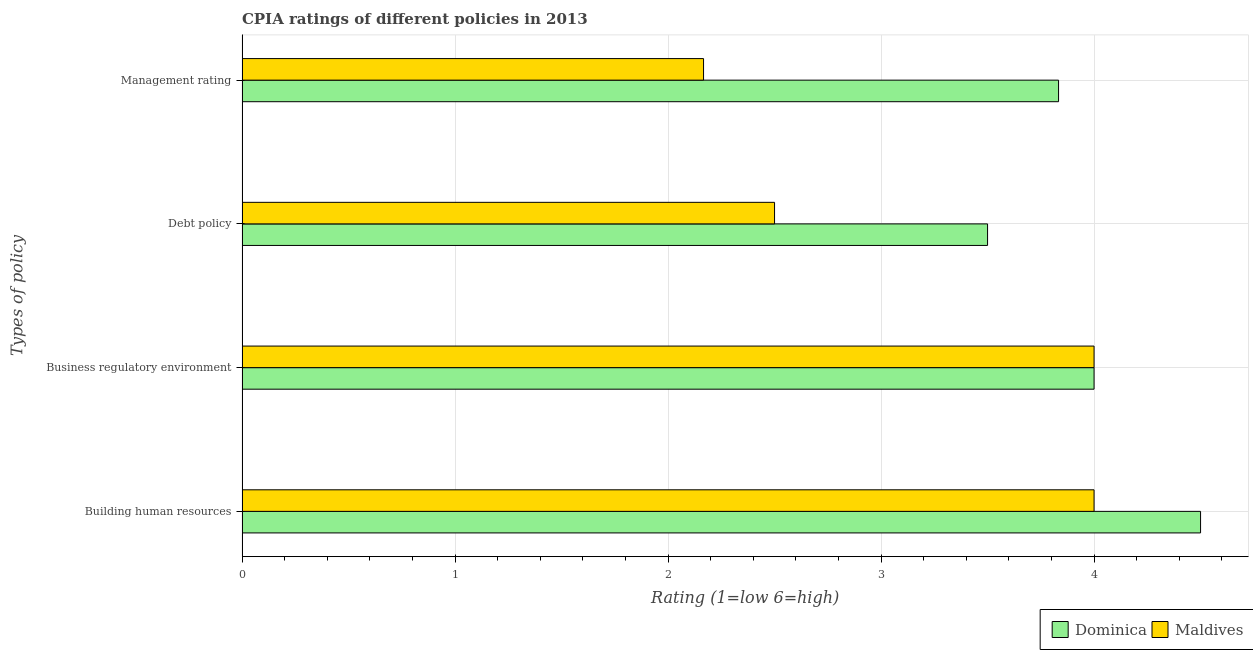Are the number of bars on each tick of the Y-axis equal?
Provide a short and direct response. Yes. How many bars are there on the 2nd tick from the top?
Offer a terse response. 2. What is the label of the 2nd group of bars from the top?
Your response must be concise. Debt policy. What is the cpia rating of debt policy in Dominica?
Provide a short and direct response. 3.5. Across all countries, what is the maximum cpia rating of management?
Make the answer very short. 3.83. In which country was the cpia rating of management maximum?
Your answer should be very brief. Dominica. In which country was the cpia rating of debt policy minimum?
Offer a very short reply. Maldives. What is the total cpia rating of building human resources in the graph?
Make the answer very short. 8.5. What is the difference between the cpia rating of debt policy in Maldives and that in Dominica?
Offer a terse response. -1. What is the difference between the cpia rating of management and cpia rating of debt policy in Maldives?
Your answer should be compact. -0.33. Is the cpia rating of management in Maldives less than that in Dominica?
Your answer should be compact. Yes. Is the difference between the cpia rating of building human resources in Dominica and Maldives greater than the difference between the cpia rating of management in Dominica and Maldives?
Give a very brief answer. No. What is the difference between the highest and the lowest cpia rating of building human resources?
Offer a very short reply. 0.5. In how many countries, is the cpia rating of building human resources greater than the average cpia rating of building human resources taken over all countries?
Your response must be concise. 1. Is the sum of the cpia rating of management in Dominica and Maldives greater than the maximum cpia rating of building human resources across all countries?
Your answer should be compact. Yes. What does the 2nd bar from the top in Management rating represents?
Your answer should be very brief. Dominica. What does the 2nd bar from the bottom in Debt policy represents?
Your answer should be compact. Maldives. How many bars are there?
Ensure brevity in your answer.  8. What is the difference between two consecutive major ticks on the X-axis?
Provide a short and direct response. 1. Are the values on the major ticks of X-axis written in scientific E-notation?
Keep it short and to the point. No. Does the graph contain grids?
Make the answer very short. Yes. Where does the legend appear in the graph?
Your response must be concise. Bottom right. How are the legend labels stacked?
Keep it short and to the point. Horizontal. What is the title of the graph?
Your answer should be very brief. CPIA ratings of different policies in 2013. What is the label or title of the Y-axis?
Provide a short and direct response. Types of policy. What is the Rating (1=low 6=high) of Dominica in Building human resources?
Provide a succinct answer. 4.5. What is the Rating (1=low 6=high) in Maldives in Building human resources?
Provide a short and direct response. 4. What is the Rating (1=low 6=high) in Dominica in Debt policy?
Provide a succinct answer. 3.5. What is the Rating (1=low 6=high) of Dominica in Management rating?
Provide a succinct answer. 3.83. What is the Rating (1=low 6=high) of Maldives in Management rating?
Give a very brief answer. 2.17. Across all Types of policy, what is the maximum Rating (1=low 6=high) of Dominica?
Give a very brief answer. 4.5. Across all Types of policy, what is the minimum Rating (1=low 6=high) of Dominica?
Provide a short and direct response. 3.5. Across all Types of policy, what is the minimum Rating (1=low 6=high) in Maldives?
Make the answer very short. 2.17. What is the total Rating (1=low 6=high) in Dominica in the graph?
Offer a terse response. 15.83. What is the total Rating (1=low 6=high) in Maldives in the graph?
Your answer should be very brief. 12.67. What is the difference between the Rating (1=low 6=high) in Dominica in Building human resources and that in Debt policy?
Provide a succinct answer. 1. What is the difference between the Rating (1=low 6=high) in Dominica in Building human resources and that in Management rating?
Make the answer very short. 0.67. What is the difference between the Rating (1=low 6=high) in Maldives in Building human resources and that in Management rating?
Your response must be concise. 1.83. What is the difference between the Rating (1=low 6=high) of Maldives in Business regulatory environment and that in Debt policy?
Your response must be concise. 1.5. What is the difference between the Rating (1=low 6=high) of Maldives in Business regulatory environment and that in Management rating?
Your answer should be compact. 1.83. What is the difference between the Rating (1=low 6=high) in Maldives in Debt policy and that in Management rating?
Provide a short and direct response. 0.33. What is the difference between the Rating (1=low 6=high) of Dominica in Building human resources and the Rating (1=low 6=high) of Maldives in Management rating?
Keep it short and to the point. 2.33. What is the difference between the Rating (1=low 6=high) of Dominica in Business regulatory environment and the Rating (1=low 6=high) of Maldives in Debt policy?
Your answer should be very brief. 1.5. What is the difference between the Rating (1=low 6=high) of Dominica in Business regulatory environment and the Rating (1=low 6=high) of Maldives in Management rating?
Your answer should be very brief. 1.83. What is the difference between the Rating (1=low 6=high) in Dominica in Debt policy and the Rating (1=low 6=high) in Maldives in Management rating?
Provide a short and direct response. 1.33. What is the average Rating (1=low 6=high) in Dominica per Types of policy?
Your answer should be compact. 3.96. What is the average Rating (1=low 6=high) in Maldives per Types of policy?
Provide a short and direct response. 3.17. What is the ratio of the Rating (1=low 6=high) in Dominica in Building human resources to that in Debt policy?
Offer a very short reply. 1.29. What is the ratio of the Rating (1=low 6=high) of Dominica in Building human resources to that in Management rating?
Keep it short and to the point. 1.17. What is the ratio of the Rating (1=low 6=high) of Maldives in Building human resources to that in Management rating?
Offer a very short reply. 1.85. What is the ratio of the Rating (1=low 6=high) in Dominica in Business regulatory environment to that in Debt policy?
Keep it short and to the point. 1.14. What is the ratio of the Rating (1=low 6=high) of Dominica in Business regulatory environment to that in Management rating?
Ensure brevity in your answer.  1.04. What is the ratio of the Rating (1=low 6=high) of Maldives in Business regulatory environment to that in Management rating?
Your answer should be very brief. 1.85. What is the ratio of the Rating (1=low 6=high) in Dominica in Debt policy to that in Management rating?
Ensure brevity in your answer.  0.91. What is the ratio of the Rating (1=low 6=high) of Maldives in Debt policy to that in Management rating?
Provide a succinct answer. 1.15. What is the difference between the highest and the second highest Rating (1=low 6=high) of Dominica?
Provide a succinct answer. 0.5. What is the difference between the highest and the lowest Rating (1=low 6=high) in Maldives?
Make the answer very short. 1.83. 